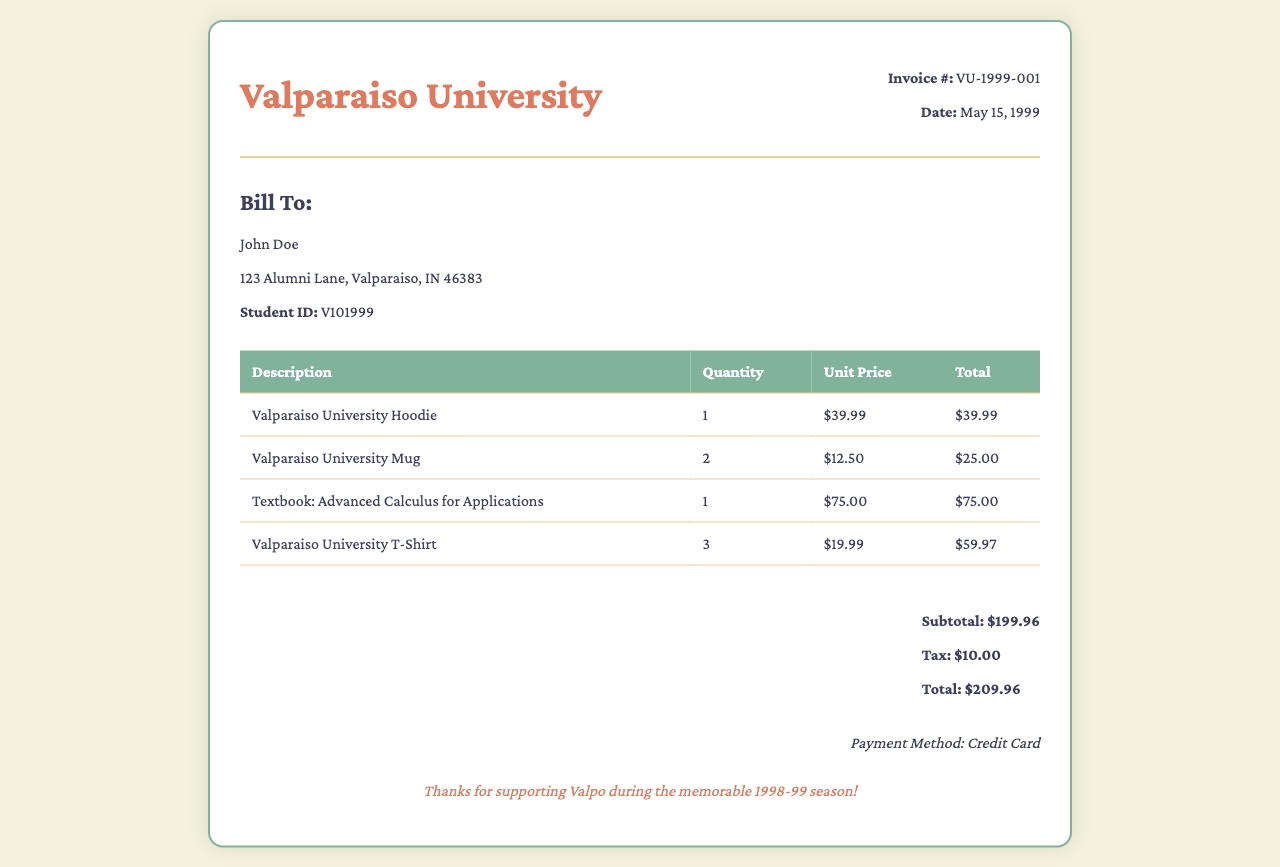What is the invoice number? The invoice number is provided in the document, it is labeled as "Invoice #".
Answer: VU-1999-001 What is the date of the invoice? The date of the invoice is mentioned under the invoice number section, indicating when the purchase was made.
Answer: May 15, 1999 Who is the bill addressed to? The billing information section specifies the name of the individual responsible for the invoice.
Answer: John Doe What is the subtotal amount? The subtotal is calculated before tax and is clearly shown in the total section of the document.
Answer: $199.96 How many Valparaiso University T-Shirts were purchased? The quantity of each item is listed in the invoice table under the respective item description.
Answer: 3 What is the total amount due? The total amount reflects the complete cost including the subtotal and tax, noted in the total section.
Answer: $209.96 What payment method was used? The payment method is stated at the bottom of the invoice, indicating how the bill was settled.
Answer: Credit Card What is the unit price of a Valparaiso University Hoodie? The unit price is listed for each item in the table of the invoice under unit price column.
Answer: $39.99 How much tax was applied to the purchase? The tax amount is specified in the total section of the invoice, detailing additional costs incurred.
Answer: $10.00 